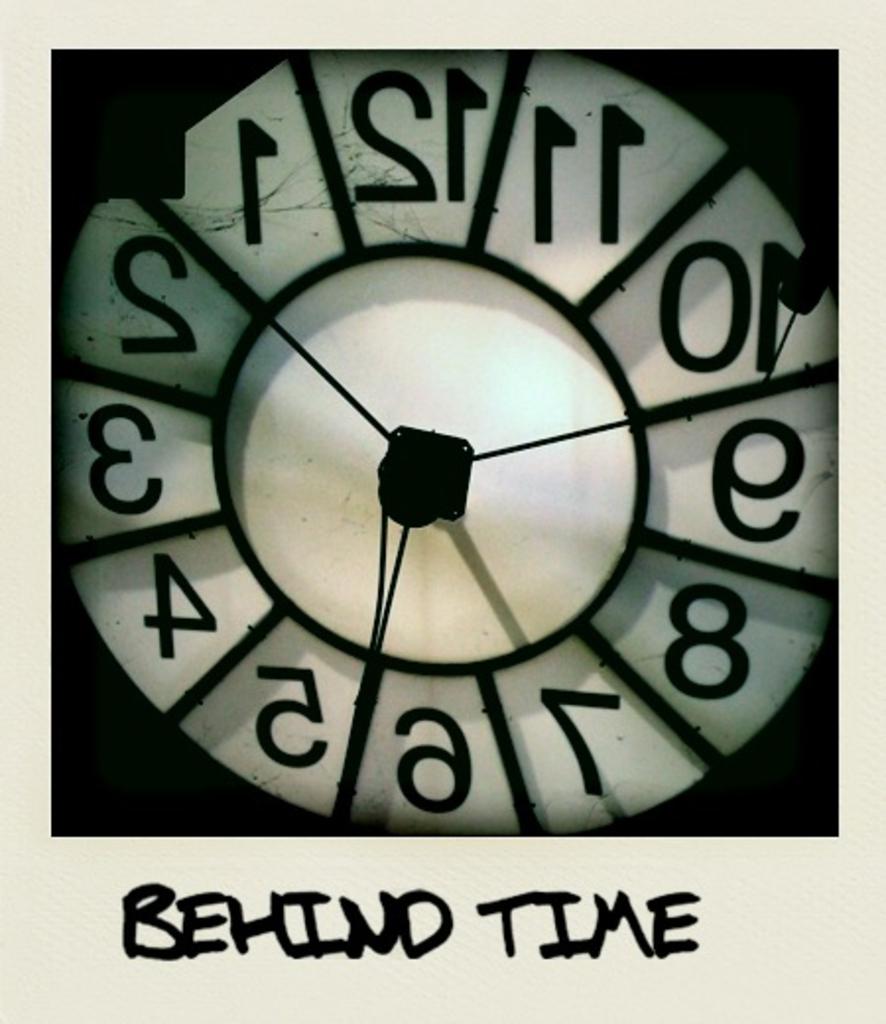What does it say at the bottom of the image?
Your answer should be compact. Behind time. 